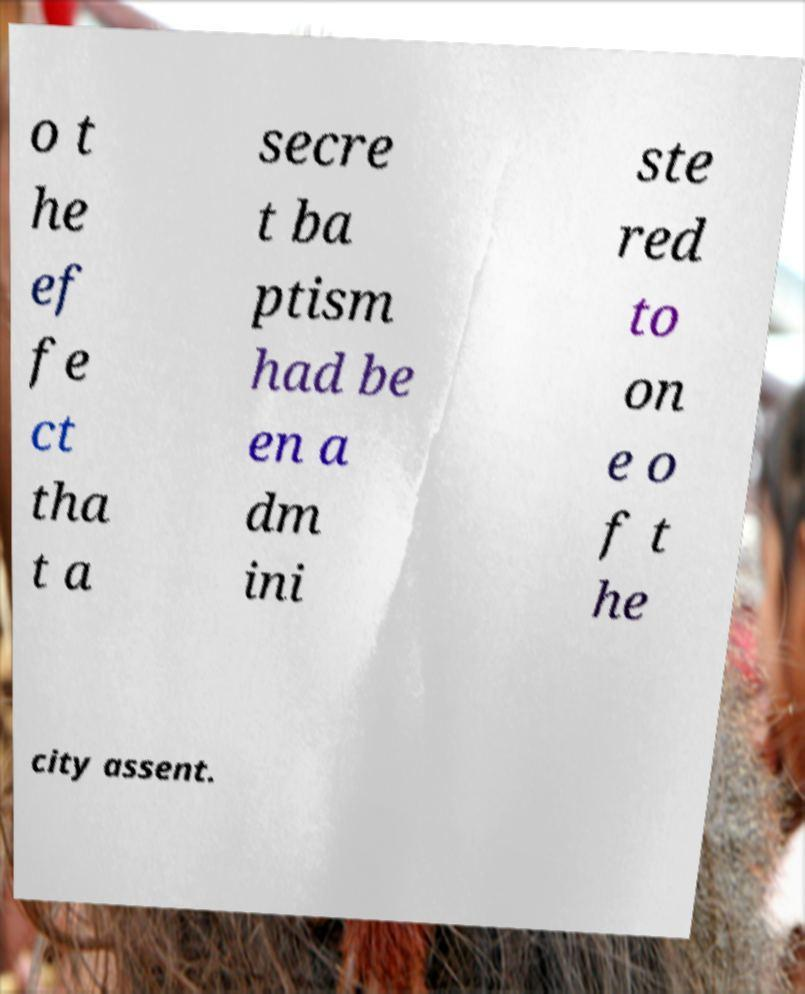Please identify and transcribe the text found in this image. o t he ef fe ct tha t a secre t ba ptism had be en a dm ini ste red to on e o f t he city assent. 